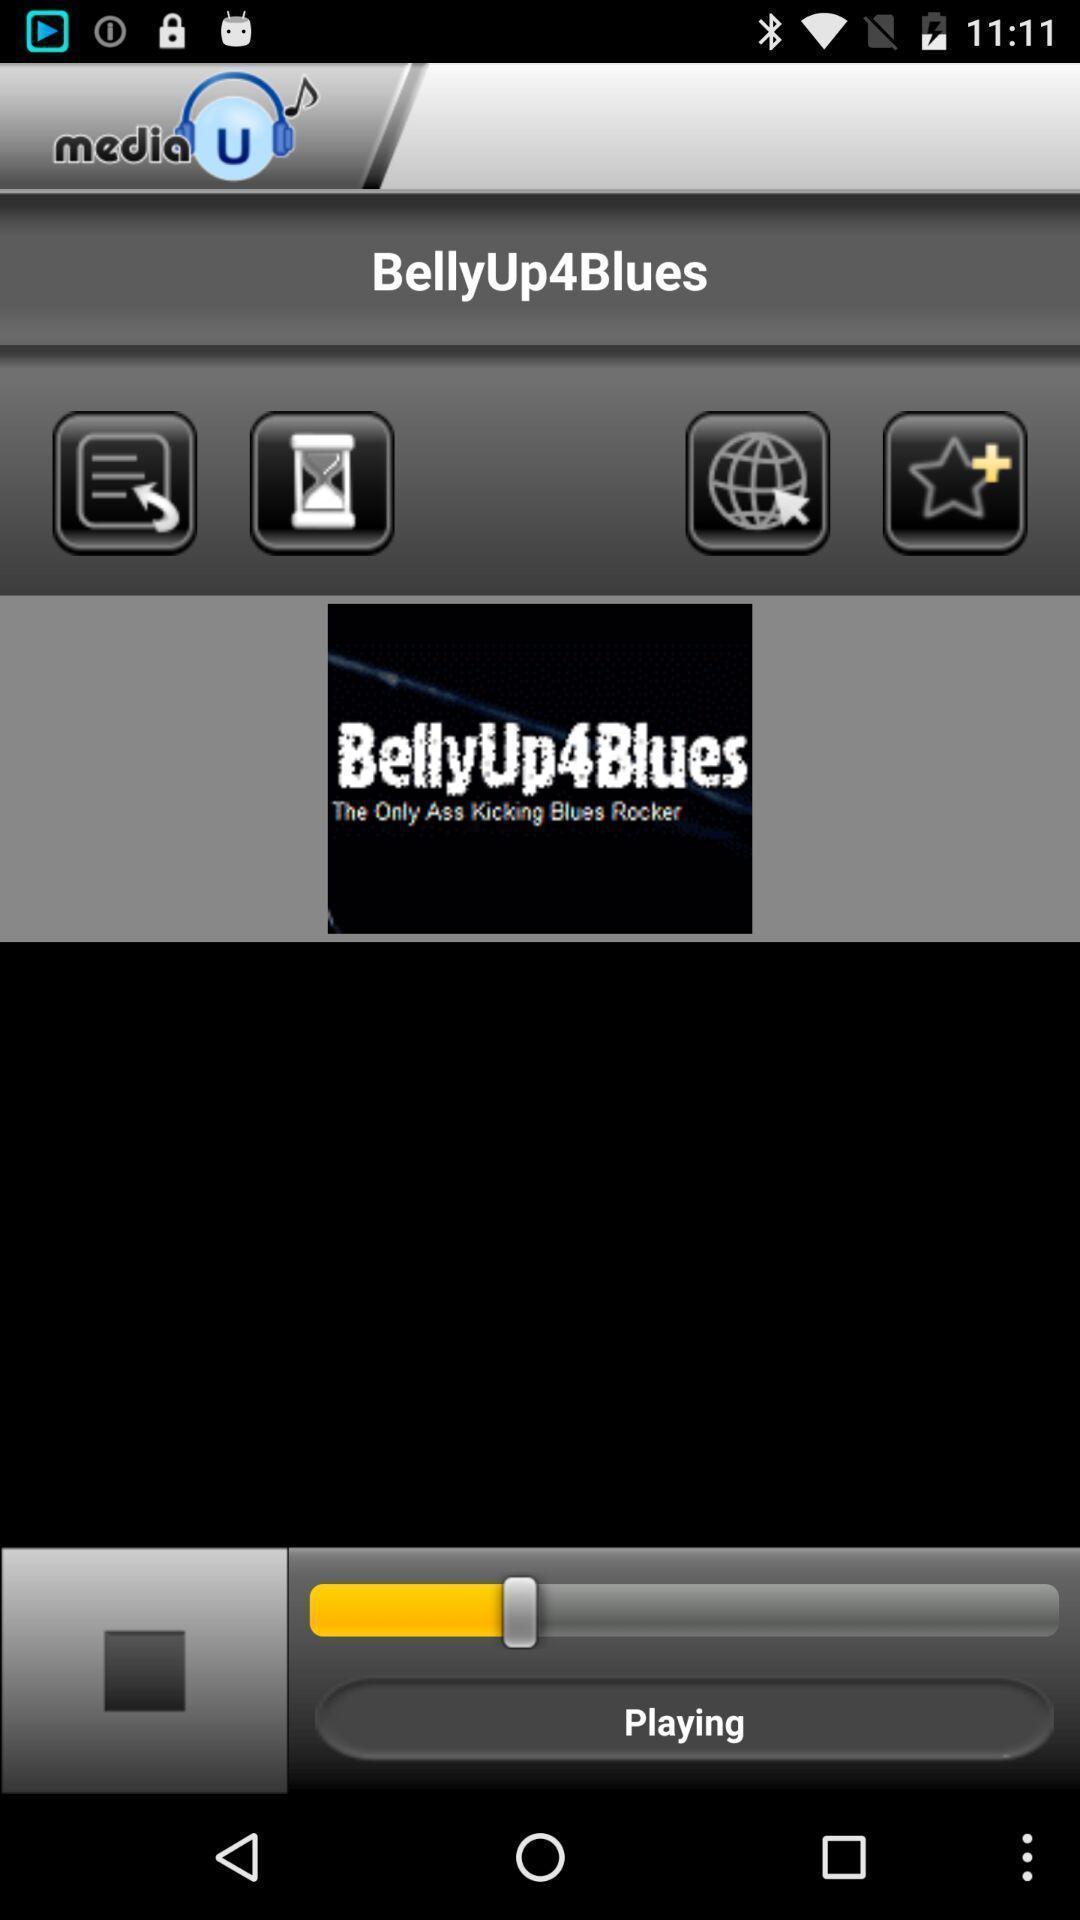Give me a narrative description of this picture. Radio playing in a music app. 